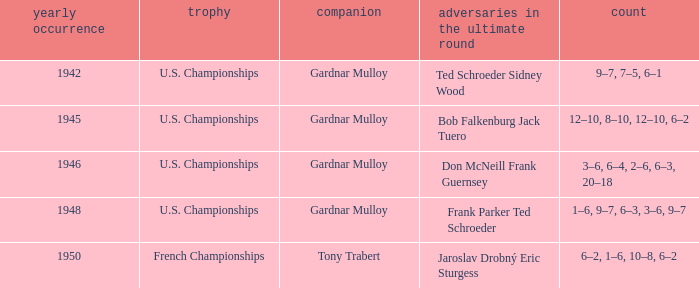What is the most recent year gardnar mulloy played as a partner and score was 12–10, 8–10, 12–10, 6–2? 1945.0. 